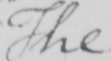Can you tell me what this handwritten text says? The 